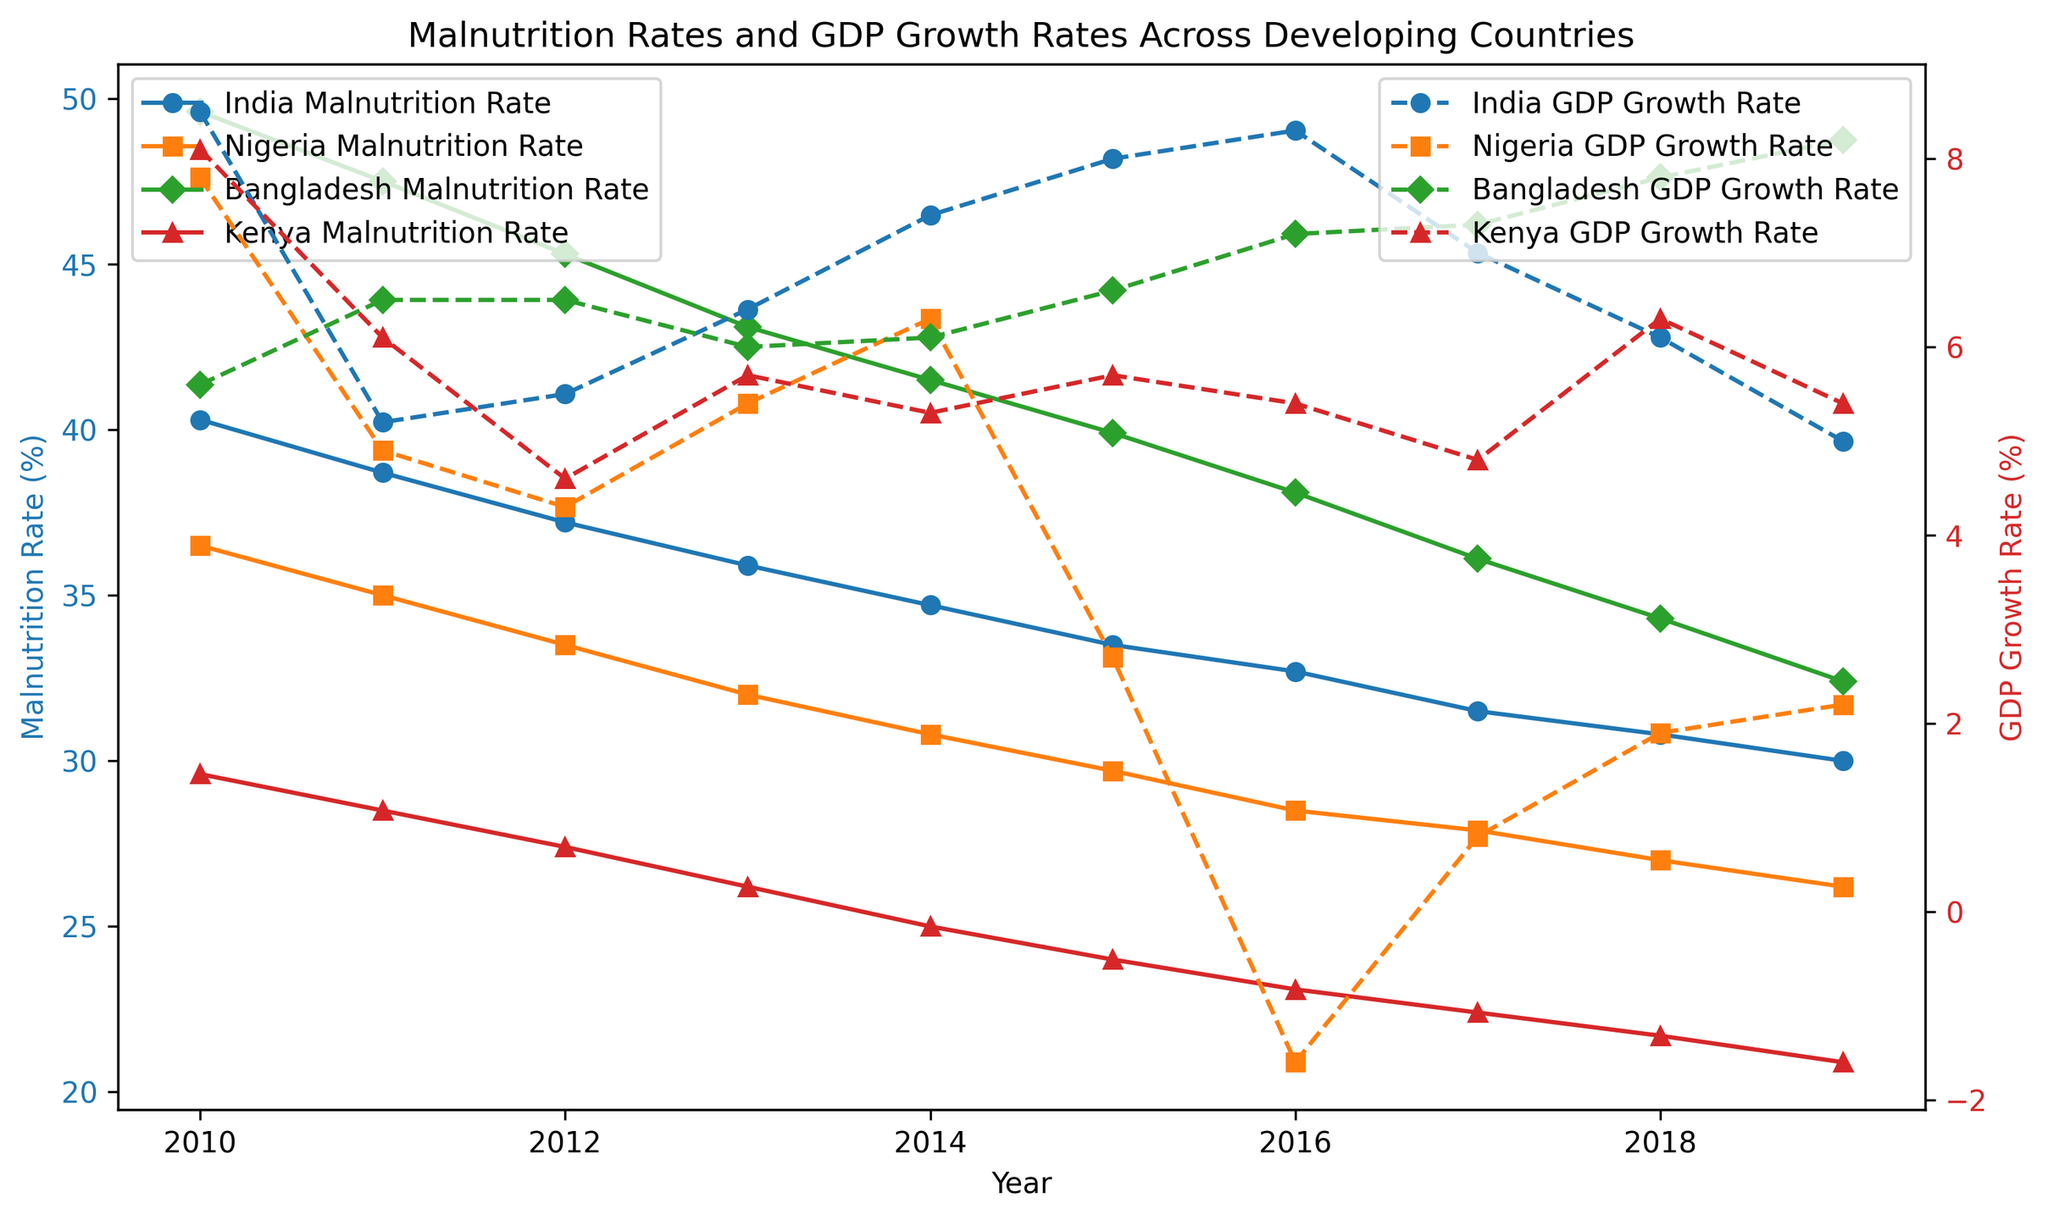What's the overall trend in malnutrition rates for India from 2010 to 2019? Looking at the plot, the malnutrition rate for India consistently decreases across the years from 40.3% in 2010 to 30.0% in 2019. This shows a clear downward trend.
Answer: Downward trend Which country shows the most significant decrease in malnutrition rates from 2010 to 2019? By comparing the start and end points for each country, Bangladesh shows the most significant decrease, from 49.6% in 2010 to 32.4% in 2019, a change of 17.2%.
Answer: Bangladesh What is the relationship between GDP growth rate and malnutrition rate for Kenya in 2015? Observing the figure, Kenya's malnutrition rate was 24.0% and the GDP growth rate was 5.7% in 2015. There doesn’t seem to be a direct correlation just from that single year’s data.
Answer: Kenya's malnutrition rate was 24.0% and GDP growth rate was 5.7% Which country experienced negative GDP growth, and in which year(s)? From the figure, it is evident that Nigeria had a negative GDP growth rate in 2016.
Answer: Nigeria in 2016 By what percentage did the malnutrition rate decrease in Bangladesh from 2010 to 2015? The malnutrition rate in Bangladesh decreased from 49.6% in 2010 to 39.9% in 2015. The percentage decrease is calculated as (49.6 - 39.9) / 49.6 * 100, which equals approximately 19.56%.
Answer: Approximately 19.56% How does the GDP growth rate in India in 2019 compare to 2010? By comparing the start and end points on the plot, India's GDP growth rate decreased from 8.5% in 2010 to 5.0% in 2019.
Answer: Decreased In which year did Nigeria have the highest GDP growth rate? Observing the plot, the highest GDP growth rate for Nigeria was in 2010 at 7.8%.
Answer: 2010 Is there a visible inverse relationship between malnutrition rate and GDP growth rate in the data for Kenya? For Kenya, as the malnutrition rate decreases steadily from 29.6% in 2010 to 20.9% in 2019, the GDP growth rate does not show a clear inverse relationship; it fluctuates without a consistent inverse trend.
Answer: No clear inverse relationship What can be said about the trend of GDP growth rate in Bangladesh from 2010 to 2019? Bangladesh shows a generally increasing trend in GDP growth rate, starting at 5.6% in 2010 and rising to 8.2% in 2019.
Answer: Generally increasing Which country had the lowest malnutrition rate in 2019, and what was the rate? By observing the figure, Kenya had the lowest malnutrition rate in 2019 at 20.9%.
Answer: Kenya at 20.9% 